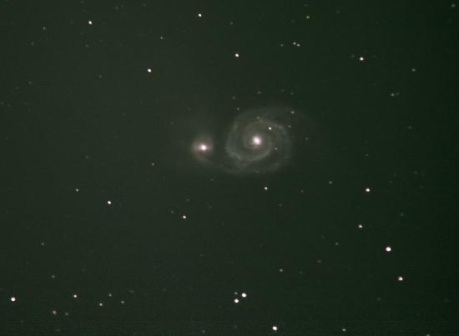What are the key elements in this picture?
 The image presents a breathtaking view of the cosmos, dominated by a spiral galaxy that sits majestically at the center. The galaxy, glowing in a radiant white hue, is characterized by a luminous core that outshines its surroundings. Its spiral arms, gracefully swirling around the core, add to the celestial spectacle.

The galaxy is not alone in this cosmic tableau. It is accompanied by a multitude of smaller white stars that are scattered across the expanse, each contributing their own twinkle to the scene. These stars, though diminutive in comparison to the central galaxy, collectively create a stellar backdrop that enhances the overall visual impact.

The backdrop itself is a canvas of dark green, a color that is often associated with the mystery and depth of space. This dark green background serves to highlight the white galaxy and stars, making them stand out prominently.

The image does not contain any discernible text or actions, and there are no other objects to count or locate. The relative positions of the stars to the galaxy and to each other appear random, as is typical in depictions of star-filled skies.

In summary, the image captures the awe-inspiring beauty and vastness of the universe, with a spiral galaxy taking center stage amidst a sea of stars against a dark green celestial backdrop. 